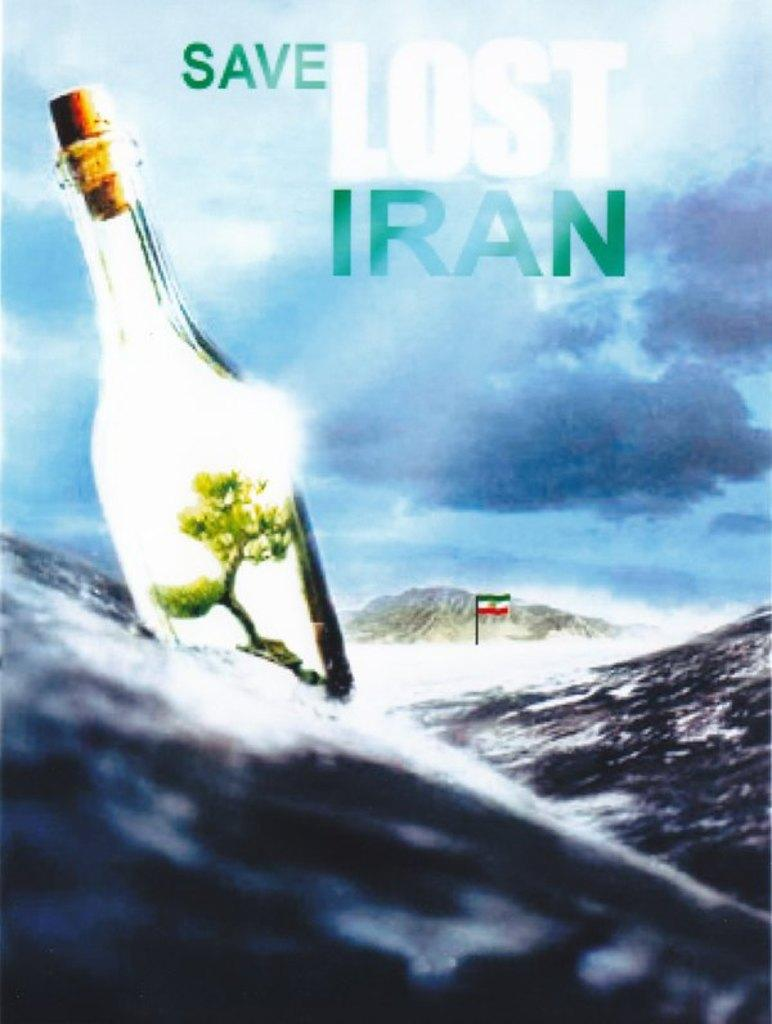<image>
Share a concise interpretation of the image provided. A poster reading Save Lost Iran next to a bottle 